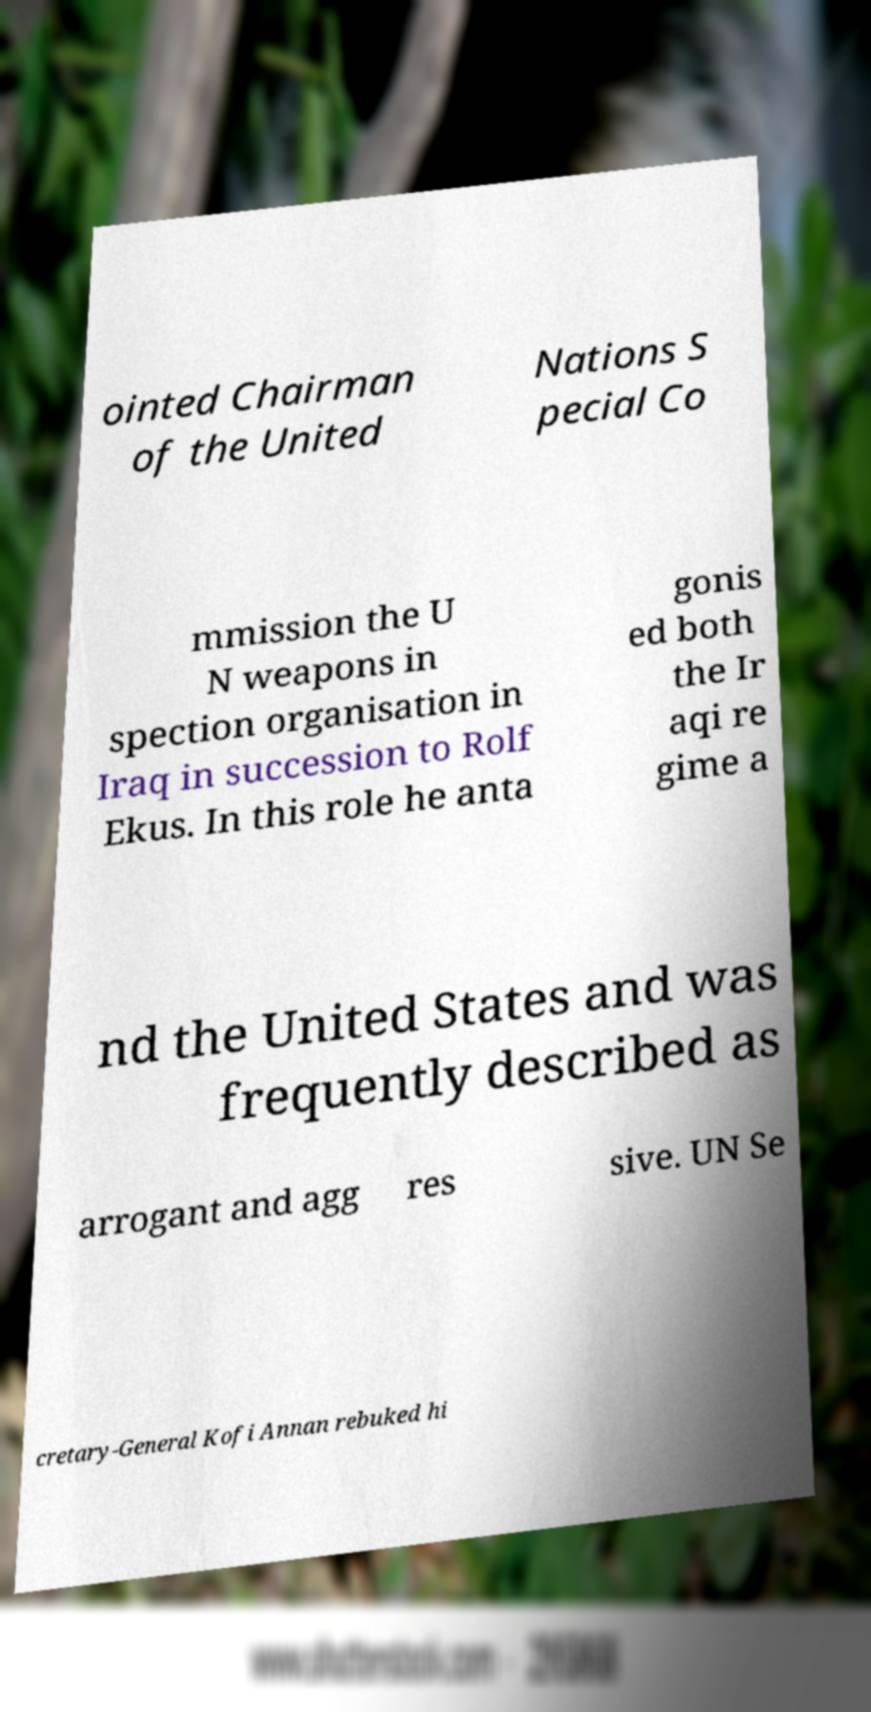Please read and relay the text visible in this image. What does it say? ointed Chairman of the United Nations S pecial Co mmission the U N weapons in spection organisation in Iraq in succession to Rolf Ekus. In this role he anta gonis ed both the Ir aqi re gime a nd the United States and was frequently described as arrogant and agg res sive. UN Se cretary-General Kofi Annan rebuked hi 